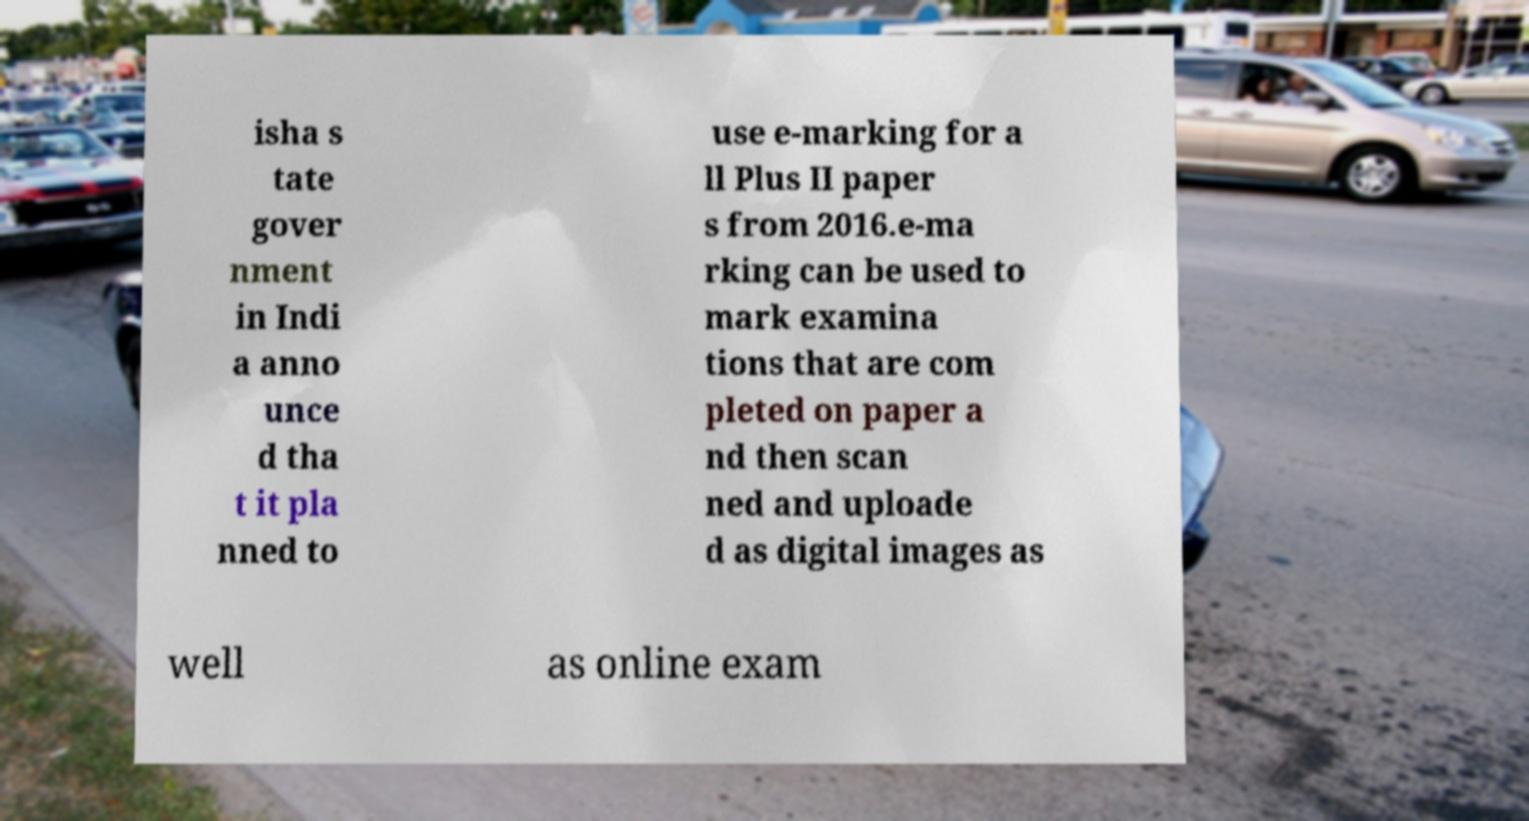What messages or text are displayed in this image? I need them in a readable, typed format. isha s tate gover nment in Indi a anno unce d tha t it pla nned to use e-marking for a ll Plus II paper s from 2016.e-ma rking can be used to mark examina tions that are com pleted on paper a nd then scan ned and uploade d as digital images as well as online exam 